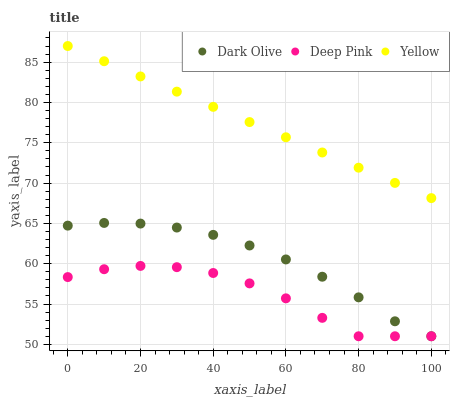Does Deep Pink have the minimum area under the curve?
Answer yes or no. Yes. Does Yellow have the maximum area under the curve?
Answer yes or no. Yes. Does Yellow have the minimum area under the curve?
Answer yes or no. No. Does Deep Pink have the maximum area under the curve?
Answer yes or no. No. Is Yellow the smoothest?
Answer yes or no. Yes. Is Deep Pink the roughest?
Answer yes or no. Yes. Is Deep Pink the smoothest?
Answer yes or no. No. Is Yellow the roughest?
Answer yes or no. No. Does Dark Olive have the lowest value?
Answer yes or no. Yes. Does Yellow have the lowest value?
Answer yes or no. No. Does Yellow have the highest value?
Answer yes or no. Yes. Does Deep Pink have the highest value?
Answer yes or no. No. Is Dark Olive less than Yellow?
Answer yes or no. Yes. Is Yellow greater than Deep Pink?
Answer yes or no. Yes. Does Deep Pink intersect Dark Olive?
Answer yes or no. Yes. Is Deep Pink less than Dark Olive?
Answer yes or no. No. Is Deep Pink greater than Dark Olive?
Answer yes or no. No. Does Dark Olive intersect Yellow?
Answer yes or no. No. 